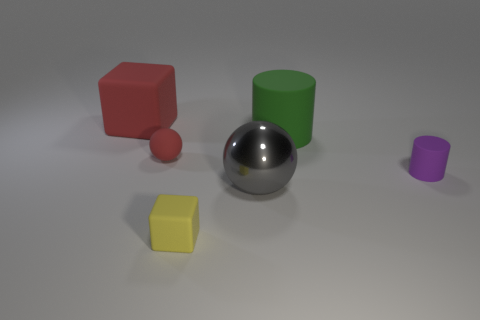Add 3 small yellow matte objects. How many objects exist? 9 Subtract all balls. How many objects are left? 4 Subtract all tiny brown shiny cylinders. Subtract all purple things. How many objects are left? 5 Add 2 gray shiny things. How many gray shiny things are left? 3 Add 3 large gray metallic balls. How many large gray metallic balls exist? 4 Subtract 1 red spheres. How many objects are left? 5 